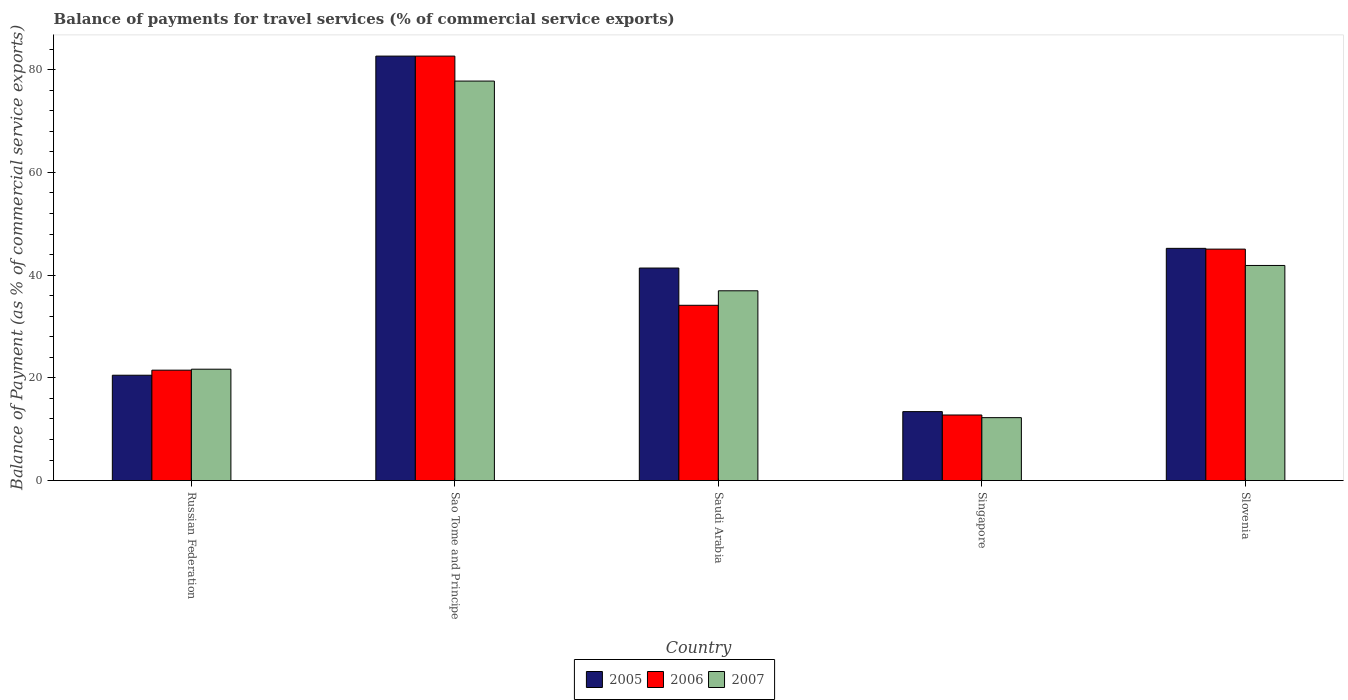How many groups of bars are there?
Your response must be concise. 5. How many bars are there on the 3rd tick from the right?
Give a very brief answer. 3. What is the label of the 3rd group of bars from the left?
Provide a short and direct response. Saudi Arabia. What is the balance of payments for travel services in 2006 in Russian Federation?
Offer a terse response. 21.5. Across all countries, what is the maximum balance of payments for travel services in 2005?
Give a very brief answer. 82.64. Across all countries, what is the minimum balance of payments for travel services in 2007?
Keep it short and to the point. 12.25. In which country was the balance of payments for travel services in 2006 maximum?
Provide a short and direct response. Sao Tome and Principe. In which country was the balance of payments for travel services in 2006 minimum?
Provide a succinct answer. Singapore. What is the total balance of payments for travel services in 2006 in the graph?
Ensure brevity in your answer.  196.1. What is the difference between the balance of payments for travel services in 2007 in Russian Federation and that in Slovenia?
Your response must be concise. -20.2. What is the difference between the balance of payments for travel services in 2005 in Saudi Arabia and the balance of payments for travel services in 2006 in Russian Federation?
Your response must be concise. 19.88. What is the average balance of payments for travel services in 2006 per country?
Your answer should be compact. 39.22. What is the difference between the balance of payments for travel services of/in 2007 and balance of payments for travel services of/in 2006 in Russian Federation?
Your answer should be very brief. 0.19. What is the ratio of the balance of payments for travel services in 2005 in Singapore to that in Slovenia?
Keep it short and to the point. 0.3. Is the balance of payments for travel services in 2006 in Saudi Arabia less than that in Slovenia?
Provide a succinct answer. Yes. Is the difference between the balance of payments for travel services in 2007 in Sao Tome and Principe and Singapore greater than the difference between the balance of payments for travel services in 2006 in Sao Tome and Principe and Singapore?
Ensure brevity in your answer.  No. What is the difference between the highest and the second highest balance of payments for travel services in 2006?
Your answer should be compact. 48.52. What is the difference between the highest and the lowest balance of payments for travel services in 2006?
Offer a terse response. 69.87. In how many countries, is the balance of payments for travel services in 2006 greater than the average balance of payments for travel services in 2006 taken over all countries?
Ensure brevity in your answer.  2. Is the sum of the balance of payments for travel services in 2005 in Russian Federation and Singapore greater than the maximum balance of payments for travel services in 2007 across all countries?
Give a very brief answer. No. What does the 2nd bar from the left in Slovenia represents?
Your answer should be very brief. 2006. What does the 3rd bar from the right in Russian Federation represents?
Give a very brief answer. 2005. Are all the bars in the graph horizontal?
Give a very brief answer. No. How many countries are there in the graph?
Make the answer very short. 5. What is the difference between two consecutive major ticks on the Y-axis?
Offer a very short reply. 20. Does the graph contain any zero values?
Your answer should be compact. No. Where does the legend appear in the graph?
Make the answer very short. Bottom center. What is the title of the graph?
Make the answer very short. Balance of payments for travel services (% of commercial service exports). Does "1977" appear as one of the legend labels in the graph?
Your answer should be very brief. No. What is the label or title of the X-axis?
Keep it short and to the point. Country. What is the label or title of the Y-axis?
Offer a terse response. Balance of Payment (as % of commercial service exports). What is the Balance of Payment (as % of commercial service exports) in 2005 in Russian Federation?
Provide a succinct answer. 20.51. What is the Balance of Payment (as % of commercial service exports) in 2006 in Russian Federation?
Make the answer very short. 21.5. What is the Balance of Payment (as % of commercial service exports) in 2007 in Russian Federation?
Offer a very short reply. 21.69. What is the Balance of Payment (as % of commercial service exports) of 2005 in Sao Tome and Principe?
Your answer should be compact. 82.64. What is the Balance of Payment (as % of commercial service exports) in 2006 in Sao Tome and Principe?
Provide a short and direct response. 82.64. What is the Balance of Payment (as % of commercial service exports) of 2007 in Sao Tome and Principe?
Ensure brevity in your answer.  77.78. What is the Balance of Payment (as % of commercial service exports) in 2005 in Saudi Arabia?
Provide a short and direct response. 41.38. What is the Balance of Payment (as % of commercial service exports) in 2006 in Saudi Arabia?
Offer a terse response. 34.13. What is the Balance of Payment (as % of commercial service exports) in 2007 in Saudi Arabia?
Provide a short and direct response. 36.95. What is the Balance of Payment (as % of commercial service exports) of 2005 in Singapore?
Keep it short and to the point. 13.43. What is the Balance of Payment (as % of commercial service exports) in 2006 in Singapore?
Offer a very short reply. 12.77. What is the Balance of Payment (as % of commercial service exports) of 2007 in Singapore?
Your answer should be very brief. 12.25. What is the Balance of Payment (as % of commercial service exports) in 2005 in Slovenia?
Your answer should be very brief. 45.21. What is the Balance of Payment (as % of commercial service exports) of 2006 in Slovenia?
Your response must be concise. 45.06. What is the Balance of Payment (as % of commercial service exports) in 2007 in Slovenia?
Your response must be concise. 41.88. Across all countries, what is the maximum Balance of Payment (as % of commercial service exports) in 2005?
Offer a very short reply. 82.64. Across all countries, what is the maximum Balance of Payment (as % of commercial service exports) of 2006?
Give a very brief answer. 82.64. Across all countries, what is the maximum Balance of Payment (as % of commercial service exports) in 2007?
Keep it short and to the point. 77.78. Across all countries, what is the minimum Balance of Payment (as % of commercial service exports) of 2005?
Offer a very short reply. 13.43. Across all countries, what is the minimum Balance of Payment (as % of commercial service exports) of 2006?
Provide a short and direct response. 12.77. Across all countries, what is the minimum Balance of Payment (as % of commercial service exports) of 2007?
Your response must be concise. 12.25. What is the total Balance of Payment (as % of commercial service exports) of 2005 in the graph?
Keep it short and to the point. 203.17. What is the total Balance of Payment (as % of commercial service exports) of 2006 in the graph?
Provide a short and direct response. 196.1. What is the total Balance of Payment (as % of commercial service exports) of 2007 in the graph?
Make the answer very short. 190.55. What is the difference between the Balance of Payment (as % of commercial service exports) of 2005 in Russian Federation and that in Sao Tome and Principe?
Give a very brief answer. -62.13. What is the difference between the Balance of Payment (as % of commercial service exports) in 2006 in Russian Federation and that in Sao Tome and Principe?
Your answer should be compact. -61.15. What is the difference between the Balance of Payment (as % of commercial service exports) of 2007 in Russian Federation and that in Sao Tome and Principe?
Provide a short and direct response. -56.1. What is the difference between the Balance of Payment (as % of commercial service exports) of 2005 in Russian Federation and that in Saudi Arabia?
Provide a succinct answer. -20.87. What is the difference between the Balance of Payment (as % of commercial service exports) in 2006 in Russian Federation and that in Saudi Arabia?
Your answer should be very brief. -12.63. What is the difference between the Balance of Payment (as % of commercial service exports) of 2007 in Russian Federation and that in Saudi Arabia?
Keep it short and to the point. -15.27. What is the difference between the Balance of Payment (as % of commercial service exports) in 2005 in Russian Federation and that in Singapore?
Ensure brevity in your answer.  7.08. What is the difference between the Balance of Payment (as % of commercial service exports) in 2006 in Russian Federation and that in Singapore?
Your answer should be compact. 8.73. What is the difference between the Balance of Payment (as % of commercial service exports) in 2007 in Russian Federation and that in Singapore?
Your response must be concise. 9.43. What is the difference between the Balance of Payment (as % of commercial service exports) of 2005 in Russian Federation and that in Slovenia?
Make the answer very short. -24.7. What is the difference between the Balance of Payment (as % of commercial service exports) in 2006 in Russian Federation and that in Slovenia?
Your response must be concise. -23.57. What is the difference between the Balance of Payment (as % of commercial service exports) of 2007 in Russian Federation and that in Slovenia?
Provide a succinct answer. -20.2. What is the difference between the Balance of Payment (as % of commercial service exports) of 2005 in Sao Tome and Principe and that in Saudi Arabia?
Your answer should be compact. 41.26. What is the difference between the Balance of Payment (as % of commercial service exports) in 2006 in Sao Tome and Principe and that in Saudi Arabia?
Offer a very short reply. 48.52. What is the difference between the Balance of Payment (as % of commercial service exports) in 2007 in Sao Tome and Principe and that in Saudi Arabia?
Provide a short and direct response. 40.83. What is the difference between the Balance of Payment (as % of commercial service exports) of 2005 in Sao Tome and Principe and that in Singapore?
Ensure brevity in your answer.  69.22. What is the difference between the Balance of Payment (as % of commercial service exports) in 2006 in Sao Tome and Principe and that in Singapore?
Provide a succinct answer. 69.87. What is the difference between the Balance of Payment (as % of commercial service exports) of 2007 in Sao Tome and Principe and that in Singapore?
Offer a very short reply. 65.53. What is the difference between the Balance of Payment (as % of commercial service exports) in 2005 in Sao Tome and Principe and that in Slovenia?
Keep it short and to the point. 37.43. What is the difference between the Balance of Payment (as % of commercial service exports) in 2006 in Sao Tome and Principe and that in Slovenia?
Give a very brief answer. 37.58. What is the difference between the Balance of Payment (as % of commercial service exports) of 2007 in Sao Tome and Principe and that in Slovenia?
Ensure brevity in your answer.  35.9. What is the difference between the Balance of Payment (as % of commercial service exports) in 2005 in Saudi Arabia and that in Singapore?
Make the answer very short. 27.95. What is the difference between the Balance of Payment (as % of commercial service exports) of 2006 in Saudi Arabia and that in Singapore?
Your response must be concise. 21.36. What is the difference between the Balance of Payment (as % of commercial service exports) in 2007 in Saudi Arabia and that in Singapore?
Ensure brevity in your answer.  24.7. What is the difference between the Balance of Payment (as % of commercial service exports) in 2005 in Saudi Arabia and that in Slovenia?
Offer a very short reply. -3.83. What is the difference between the Balance of Payment (as % of commercial service exports) in 2006 in Saudi Arabia and that in Slovenia?
Make the answer very short. -10.94. What is the difference between the Balance of Payment (as % of commercial service exports) of 2007 in Saudi Arabia and that in Slovenia?
Offer a very short reply. -4.93. What is the difference between the Balance of Payment (as % of commercial service exports) in 2005 in Singapore and that in Slovenia?
Ensure brevity in your answer.  -31.79. What is the difference between the Balance of Payment (as % of commercial service exports) in 2006 in Singapore and that in Slovenia?
Offer a very short reply. -32.29. What is the difference between the Balance of Payment (as % of commercial service exports) in 2007 in Singapore and that in Slovenia?
Make the answer very short. -29.63. What is the difference between the Balance of Payment (as % of commercial service exports) in 2005 in Russian Federation and the Balance of Payment (as % of commercial service exports) in 2006 in Sao Tome and Principe?
Offer a very short reply. -62.13. What is the difference between the Balance of Payment (as % of commercial service exports) of 2005 in Russian Federation and the Balance of Payment (as % of commercial service exports) of 2007 in Sao Tome and Principe?
Offer a very short reply. -57.27. What is the difference between the Balance of Payment (as % of commercial service exports) of 2006 in Russian Federation and the Balance of Payment (as % of commercial service exports) of 2007 in Sao Tome and Principe?
Give a very brief answer. -56.29. What is the difference between the Balance of Payment (as % of commercial service exports) in 2005 in Russian Federation and the Balance of Payment (as % of commercial service exports) in 2006 in Saudi Arabia?
Keep it short and to the point. -13.61. What is the difference between the Balance of Payment (as % of commercial service exports) of 2005 in Russian Federation and the Balance of Payment (as % of commercial service exports) of 2007 in Saudi Arabia?
Offer a very short reply. -16.44. What is the difference between the Balance of Payment (as % of commercial service exports) in 2006 in Russian Federation and the Balance of Payment (as % of commercial service exports) in 2007 in Saudi Arabia?
Offer a very short reply. -15.45. What is the difference between the Balance of Payment (as % of commercial service exports) of 2005 in Russian Federation and the Balance of Payment (as % of commercial service exports) of 2006 in Singapore?
Your answer should be very brief. 7.74. What is the difference between the Balance of Payment (as % of commercial service exports) of 2005 in Russian Federation and the Balance of Payment (as % of commercial service exports) of 2007 in Singapore?
Offer a very short reply. 8.26. What is the difference between the Balance of Payment (as % of commercial service exports) of 2006 in Russian Federation and the Balance of Payment (as % of commercial service exports) of 2007 in Singapore?
Provide a succinct answer. 9.25. What is the difference between the Balance of Payment (as % of commercial service exports) of 2005 in Russian Federation and the Balance of Payment (as % of commercial service exports) of 2006 in Slovenia?
Keep it short and to the point. -24.55. What is the difference between the Balance of Payment (as % of commercial service exports) of 2005 in Russian Federation and the Balance of Payment (as % of commercial service exports) of 2007 in Slovenia?
Ensure brevity in your answer.  -21.37. What is the difference between the Balance of Payment (as % of commercial service exports) of 2006 in Russian Federation and the Balance of Payment (as % of commercial service exports) of 2007 in Slovenia?
Make the answer very short. -20.38. What is the difference between the Balance of Payment (as % of commercial service exports) in 2005 in Sao Tome and Principe and the Balance of Payment (as % of commercial service exports) in 2006 in Saudi Arabia?
Your answer should be very brief. 48.52. What is the difference between the Balance of Payment (as % of commercial service exports) of 2005 in Sao Tome and Principe and the Balance of Payment (as % of commercial service exports) of 2007 in Saudi Arabia?
Ensure brevity in your answer.  45.69. What is the difference between the Balance of Payment (as % of commercial service exports) of 2006 in Sao Tome and Principe and the Balance of Payment (as % of commercial service exports) of 2007 in Saudi Arabia?
Your answer should be compact. 45.69. What is the difference between the Balance of Payment (as % of commercial service exports) of 2005 in Sao Tome and Principe and the Balance of Payment (as % of commercial service exports) of 2006 in Singapore?
Your answer should be very brief. 69.87. What is the difference between the Balance of Payment (as % of commercial service exports) in 2005 in Sao Tome and Principe and the Balance of Payment (as % of commercial service exports) in 2007 in Singapore?
Your answer should be very brief. 70.39. What is the difference between the Balance of Payment (as % of commercial service exports) in 2006 in Sao Tome and Principe and the Balance of Payment (as % of commercial service exports) in 2007 in Singapore?
Your response must be concise. 70.39. What is the difference between the Balance of Payment (as % of commercial service exports) of 2005 in Sao Tome and Principe and the Balance of Payment (as % of commercial service exports) of 2006 in Slovenia?
Provide a short and direct response. 37.58. What is the difference between the Balance of Payment (as % of commercial service exports) in 2005 in Sao Tome and Principe and the Balance of Payment (as % of commercial service exports) in 2007 in Slovenia?
Your answer should be very brief. 40.76. What is the difference between the Balance of Payment (as % of commercial service exports) in 2006 in Sao Tome and Principe and the Balance of Payment (as % of commercial service exports) in 2007 in Slovenia?
Your response must be concise. 40.76. What is the difference between the Balance of Payment (as % of commercial service exports) in 2005 in Saudi Arabia and the Balance of Payment (as % of commercial service exports) in 2006 in Singapore?
Ensure brevity in your answer.  28.61. What is the difference between the Balance of Payment (as % of commercial service exports) of 2005 in Saudi Arabia and the Balance of Payment (as % of commercial service exports) of 2007 in Singapore?
Ensure brevity in your answer.  29.13. What is the difference between the Balance of Payment (as % of commercial service exports) in 2006 in Saudi Arabia and the Balance of Payment (as % of commercial service exports) in 2007 in Singapore?
Keep it short and to the point. 21.87. What is the difference between the Balance of Payment (as % of commercial service exports) of 2005 in Saudi Arabia and the Balance of Payment (as % of commercial service exports) of 2006 in Slovenia?
Ensure brevity in your answer.  -3.69. What is the difference between the Balance of Payment (as % of commercial service exports) of 2005 in Saudi Arabia and the Balance of Payment (as % of commercial service exports) of 2007 in Slovenia?
Provide a succinct answer. -0.5. What is the difference between the Balance of Payment (as % of commercial service exports) of 2006 in Saudi Arabia and the Balance of Payment (as % of commercial service exports) of 2007 in Slovenia?
Your response must be concise. -7.75. What is the difference between the Balance of Payment (as % of commercial service exports) in 2005 in Singapore and the Balance of Payment (as % of commercial service exports) in 2006 in Slovenia?
Provide a short and direct response. -31.64. What is the difference between the Balance of Payment (as % of commercial service exports) of 2005 in Singapore and the Balance of Payment (as % of commercial service exports) of 2007 in Slovenia?
Offer a terse response. -28.45. What is the difference between the Balance of Payment (as % of commercial service exports) of 2006 in Singapore and the Balance of Payment (as % of commercial service exports) of 2007 in Slovenia?
Provide a short and direct response. -29.11. What is the average Balance of Payment (as % of commercial service exports) of 2005 per country?
Keep it short and to the point. 40.63. What is the average Balance of Payment (as % of commercial service exports) of 2006 per country?
Offer a terse response. 39.22. What is the average Balance of Payment (as % of commercial service exports) of 2007 per country?
Provide a succinct answer. 38.11. What is the difference between the Balance of Payment (as % of commercial service exports) in 2005 and Balance of Payment (as % of commercial service exports) in 2006 in Russian Federation?
Make the answer very short. -0.99. What is the difference between the Balance of Payment (as % of commercial service exports) of 2005 and Balance of Payment (as % of commercial service exports) of 2007 in Russian Federation?
Your answer should be compact. -1.17. What is the difference between the Balance of Payment (as % of commercial service exports) in 2006 and Balance of Payment (as % of commercial service exports) in 2007 in Russian Federation?
Provide a short and direct response. -0.19. What is the difference between the Balance of Payment (as % of commercial service exports) in 2005 and Balance of Payment (as % of commercial service exports) in 2007 in Sao Tome and Principe?
Your answer should be very brief. 4.86. What is the difference between the Balance of Payment (as % of commercial service exports) of 2006 and Balance of Payment (as % of commercial service exports) of 2007 in Sao Tome and Principe?
Your answer should be compact. 4.86. What is the difference between the Balance of Payment (as % of commercial service exports) in 2005 and Balance of Payment (as % of commercial service exports) in 2006 in Saudi Arabia?
Your answer should be compact. 7.25. What is the difference between the Balance of Payment (as % of commercial service exports) of 2005 and Balance of Payment (as % of commercial service exports) of 2007 in Saudi Arabia?
Provide a succinct answer. 4.43. What is the difference between the Balance of Payment (as % of commercial service exports) in 2006 and Balance of Payment (as % of commercial service exports) in 2007 in Saudi Arabia?
Your response must be concise. -2.82. What is the difference between the Balance of Payment (as % of commercial service exports) in 2005 and Balance of Payment (as % of commercial service exports) in 2006 in Singapore?
Your response must be concise. 0.66. What is the difference between the Balance of Payment (as % of commercial service exports) of 2005 and Balance of Payment (as % of commercial service exports) of 2007 in Singapore?
Provide a short and direct response. 1.17. What is the difference between the Balance of Payment (as % of commercial service exports) of 2006 and Balance of Payment (as % of commercial service exports) of 2007 in Singapore?
Ensure brevity in your answer.  0.52. What is the difference between the Balance of Payment (as % of commercial service exports) in 2005 and Balance of Payment (as % of commercial service exports) in 2006 in Slovenia?
Ensure brevity in your answer.  0.15. What is the difference between the Balance of Payment (as % of commercial service exports) in 2005 and Balance of Payment (as % of commercial service exports) in 2007 in Slovenia?
Your answer should be very brief. 3.33. What is the difference between the Balance of Payment (as % of commercial service exports) in 2006 and Balance of Payment (as % of commercial service exports) in 2007 in Slovenia?
Provide a succinct answer. 3.18. What is the ratio of the Balance of Payment (as % of commercial service exports) in 2005 in Russian Federation to that in Sao Tome and Principe?
Your response must be concise. 0.25. What is the ratio of the Balance of Payment (as % of commercial service exports) of 2006 in Russian Federation to that in Sao Tome and Principe?
Provide a succinct answer. 0.26. What is the ratio of the Balance of Payment (as % of commercial service exports) in 2007 in Russian Federation to that in Sao Tome and Principe?
Your response must be concise. 0.28. What is the ratio of the Balance of Payment (as % of commercial service exports) of 2005 in Russian Federation to that in Saudi Arabia?
Offer a terse response. 0.5. What is the ratio of the Balance of Payment (as % of commercial service exports) of 2006 in Russian Federation to that in Saudi Arabia?
Your answer should be compact. 0.63. What is the ratio of the Balance of Payment (as % of commercial service exports) in 2007 in Russian Federation to that in Saudi Arabia?
Ensure brevity in your answer.  0.59. What is the ratio of the Balance of Payment (as % of commercial service exports) of 2005 in Russian Federation to that in Singapore?
Your answer should be compact. 1.53. What is the ratio of the Balance of Payment (as % of commercial service exports) in 2006 in Russian Federation to that in Singapore?
Keep it short and to the point. 1.68. What is the ratio of the Balance of Payment (as % of commercial service exports) of 2007 in Russian Federation to that in Singapore?
Make the answer very short. 1.77. What is the ratio of the Balance of Payment (as % of commercial service exports) of 2005 in Russian Federation to that in Slovenia?
Offer a very short reply. 0.45. What is the ratio of the Balance of Payment (as % of commercial service exports) of 2006 in Russian Federation to that in Slovenia?
Give a very brief answer. 0.48. What is the ratio of the Balance of Payment (as % of commercial service exports) in 2007 in Russian Federation to that in Slovenia?
Provide a succinct answer. 0.52. What is the ratio of the Balance of Payment (as % of commercial service exports) in 2005 in Sao Tome and Principe to that in Saudi Arabia?
Your answer should be very brief. 2. What is the ratio of the Balance of Payment (as % of commercial service exports) of 2006 in Sao Tome and Principe to that in Saudi Arabia?
Ensure brevity in your answer.  2.42. What is the ratio of the Balance of Payment (as % of commercial service exports) in 2007 in Sao Tome and Principe to that in Saudi Arabia?
Your answer should be very brief. 2.1. What is the ratio of the Balance of Payment (as % of commercial service exports) in 2005 in Sao Tome and Principe to that in Singapore?
Offer a very short reply. 6.15. What is the ratio of the Balance of Payment (as % of commercial service exports) in 2006 in Sao Tome and Principe to that in Singapore?
Provide a short and direct response. 6.47. What is the ratio of the Balance of Payment (as % of commercial service exports) of 2007 in Sao Tome and Principe to that in Singapore?
Make the answer very short. 6.35. What is the ratio of the Balance of Payment (as % of commercial service exports) in 2005 in Sao Tome and Principe to that in Slovenia?
Give a very brief answer. 1.83. What is the ratio of the Balance of Payment (as % of commercial service exports) in 2006 in Sao Tome and Principe to that in Slovenia?
Offer a terse response. 1.83. What is the ratio of the Balance of Payment (as % of commercial service exports) in 2007 in Sao Tome and Principe to that in Slovenia?
Provide a short and direct response. 1.86. What is the ratio of the Balance of Payment (as % of commercial service exports) of 2005 in Saudi Arabia to that in Singapore?
Your answer should be very brief. 3.08. What is the ratio of the Balance of Payment (as % of commercial service exports) of 2006 in Saudi Arabia to that in Singapore?
Your response must be concise. 2.67. What is the ratio of the Balance of Payment (as % of commercial service exports) of 2007 in Saudi Arabia to that in Singapore?
Provide a succinct answer. 3.02. What is the ratio of the Balance of Payment (as % of commercial service exports) in 2005 in Saudi Arabia to that in Slovenia?
Give a very brief answer. 0.92. What is the ratio of the Balance of Payment (as % of commercial service exports) in 2006 in Saudi Arabia to that in Slovenia?
Provide a succinct answer. 0.76. What is the ratio of the Balance of Payment (as % of commercial service exports) of 2007 in Saudi Arabia to that in Slovenia?
Offer a terse response. 0.88. What is the ratio of the Balance of Payment (as % of commercial service exports) in 2005 in Singapore to that in Slovenia?
Your answer should be compact. 0.3. What is the ratio of the Balance of Payment (as % of commercial service exports) of 2006 in Singapore to that in Slovenia?
Keep it short and to the point. 0.28. What is the ratio of the Balance of Payment (as % of commercial service exports) of 2007 in Singapore to that in Slovenia?
Your response must be concise. 0.29. What is the difference between the highest and the second highest Balance of Payment (as % of commercial service exports) in 2005?
Your response must be concise. 37.43. What is the difference between the highest and the second highest Balance of Payment (as % of commercial service exports) in 2006?
Keep it short and to the point. 37.58. What is the difference between the highest and the second highest Balance of Payment (as % of commercial service exports) of 2007?
Give a very brief answer. 35.9. What is the difference between the highest and the lowest Balance of Payment (as % of commercial service exports) of 2005?
Your answer should be compact. 69.22. What is the difference between the highest and the lowest Balance of Payment (as % of commercial service exports) of 2006?
Your answer should be very brief. 69.87. What is the difference between the highest and the lowest Balance of Payment (as % of commercial service exports) in 2007?
Your answer should be very brief. 65.53. 